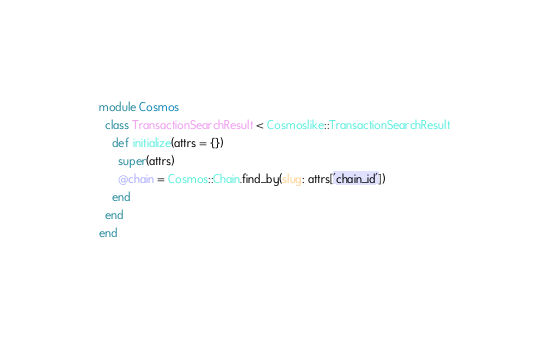<code> <loc_0><loc_0><loc_500><loc_500><_Ruby_>module Cosmos
  class TransactionSearchResult < Cosmoslike::TransactionSearchResult
    def initialize(attrs = {})
      super(attrs)
      @chain = Cosmos::Chain.find_by(slug: attrs['chain_id'])
    end
  end
end
</code> 